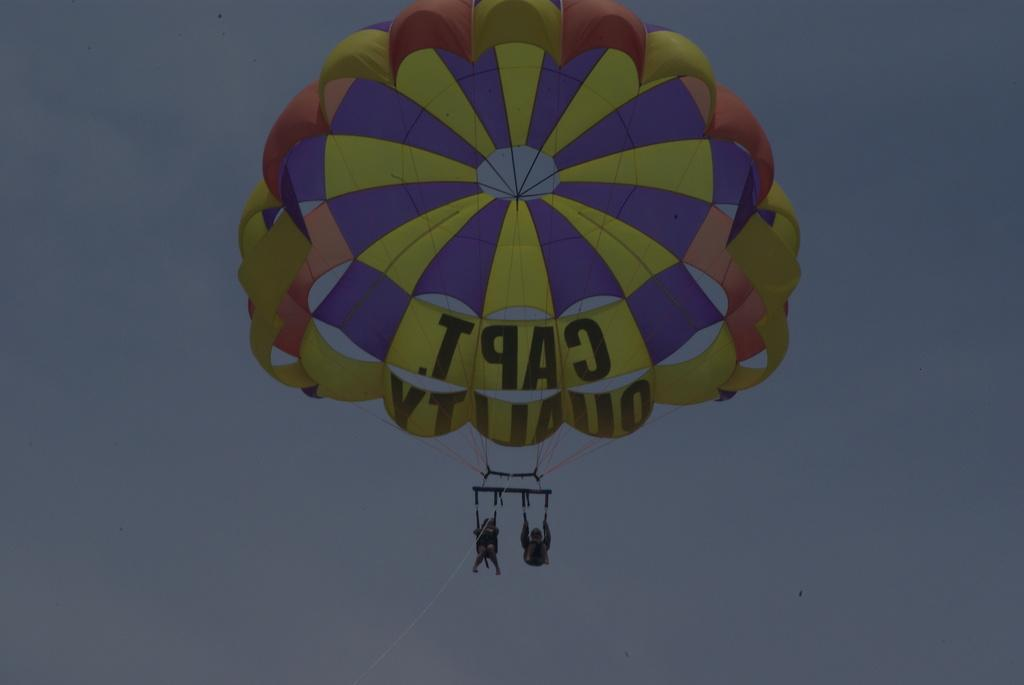How many people are in the image? There are two persons in the image. What are the persons doing in the image? The persons are diving with a parachute. From where is the diving taking place? The diving is taking place from the sky. What type of gun is being used by the persons in the image? There is no gun present in the image; the persons are diving with a parachute. How does the credit system work in the image? There is no reference to a credit system in the image; it features two persons diving with a parachute. 